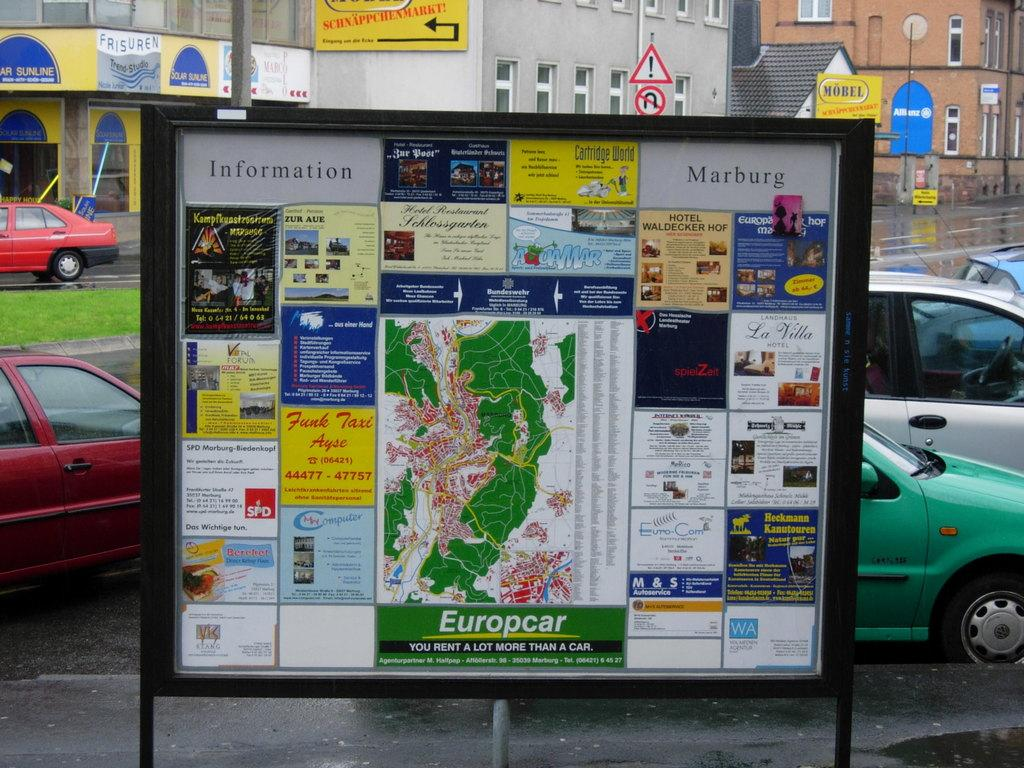Provide a one-sentence caption for the provided image. a sign on a board that says Europcar on it. 